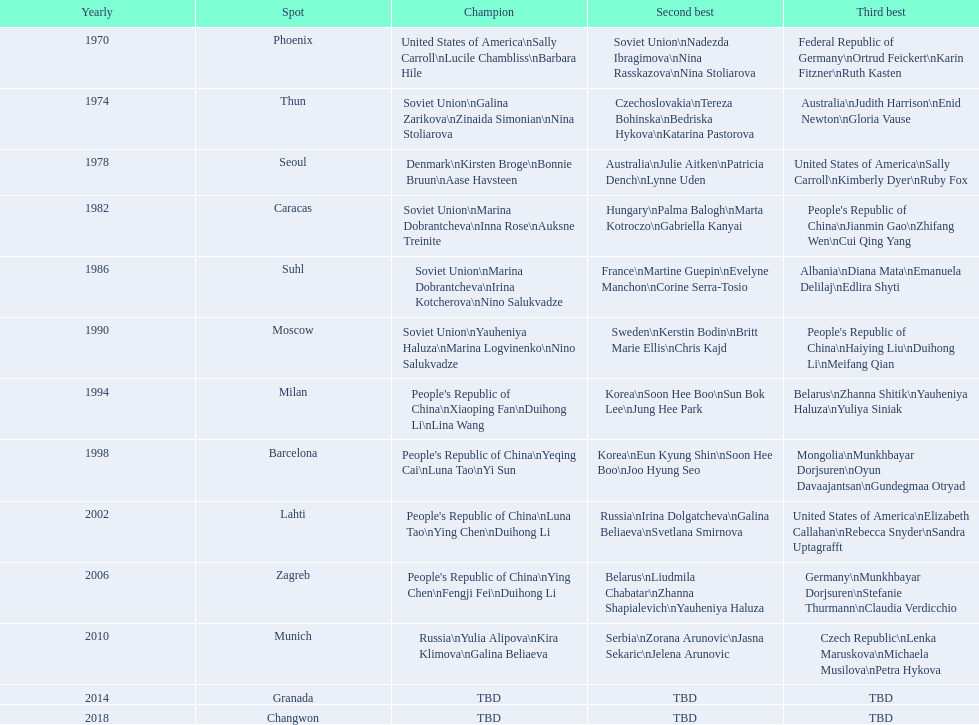What is the count of bronze medals won by germany? 2. 